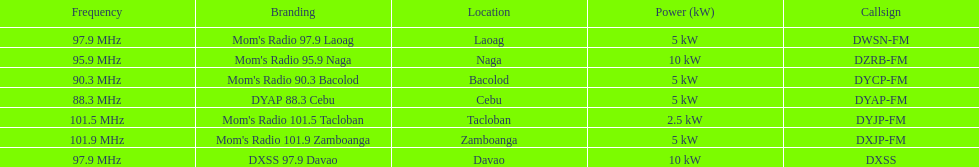What is the number of these stations broadcasting at a frequency of greater than 100 mhz? 2. 